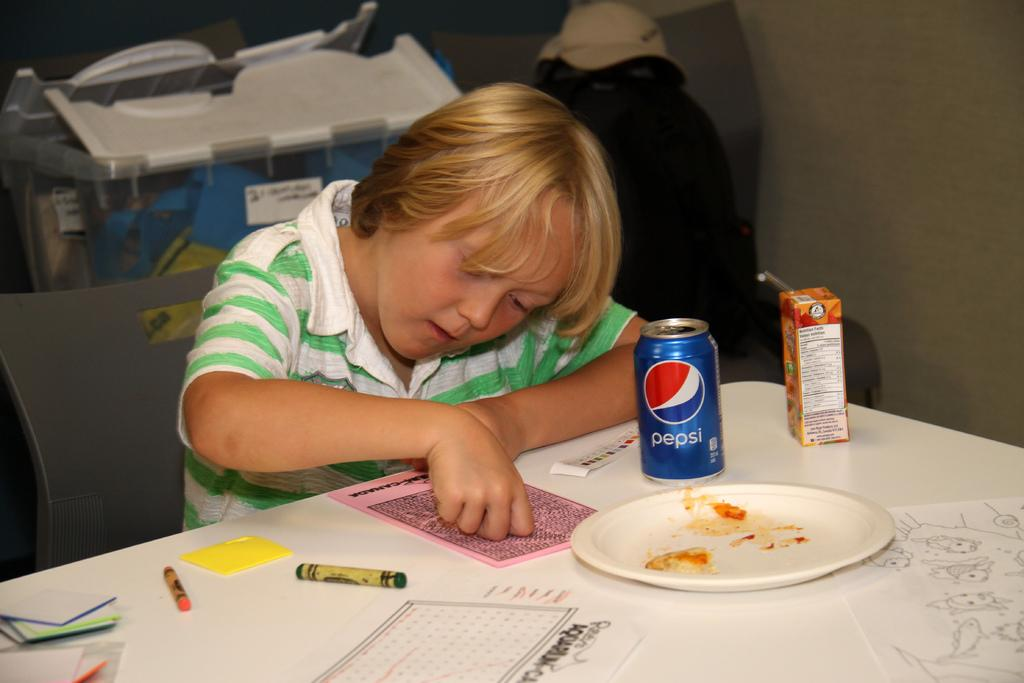<image>
Write a terse but informative summary of the picture. A boy works as he sits by a table with a dirty plate and can of Pepsi. 